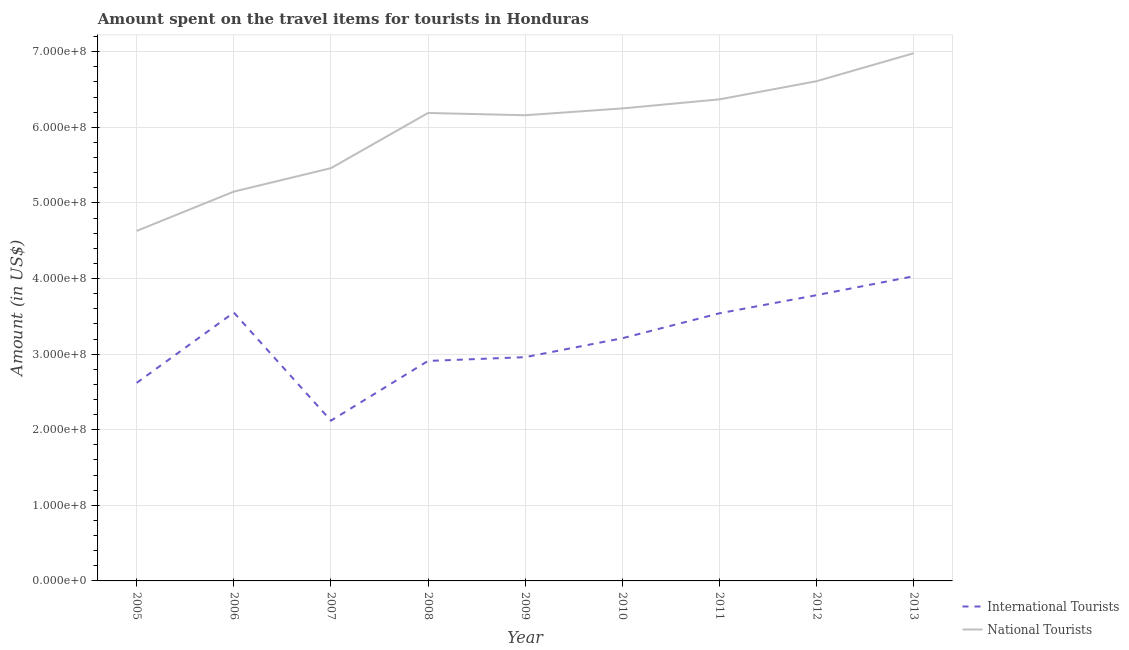Does the line corresponding to amount spent on travel items of national tourists intersect with the line corresponding to amount spent on travel items of international tourists?
Provide a succinct answer. No. What is the amount spent on travel items of international tourists in 2007?
Keep it short and to the point. 2.12e+08. Across all years, what is the maximum amount spent on travel items of international tourists?
Offer a terse response. 4.03e+08. Across all years, what is the minimum amount spent on travel items of national tourists?
Give a very brief answer. 4.63e+08. In which year was the amount spent on travel items of international tourists maximum?
Give a very brief answer. 2013. In which year was the amount spent on travel items of international tourists minimum?
Your answer should be very brief. 2007. What is the total amount spent on travel items of national tourists in the graph?
Provide a short and direct response. 5.38e+09. What is the difference between the amount spent on travel items of national tourists in 2005 and that in 2009?
Give a very brief answer. -1.53e+08. What is the difference between the amount spent on travel items of international tourists in 2013 and the amount spent on travel items of national tourists in 2009?
Provide a succinct answer. -2.13e+08. What is the average amount spent on travel items of international tourists per year?
Offer a terse response. 3.19e+08. In the year 2010, what is the difference between the amount spent on travel items of national tourists and amount spent on travel items of international tourists?
Your answer should be compact. 3.04e+08. In how many years, is the amount spent on travel items of national tourists greater than 560000000 US$?
Provide a succinct answer. 6. What is the ratio of the amount spent on travel items of international tourists in 2007 to that in 2009?
Your answer should be very brief. 0.72. What is the difference between the highest and the second highest amount spent on travel items of national tourists?
Provide a short and direct response. 3.70e+07. What is the difference between the highest and the lowest amount spent on travel items of international tourists?
Provide a succinct answer. 1.91e+08. In how many years, is the amount spent on travel items of international tourists greater than the average amount spent on travel items of international tourists taken over all years?
Offer a terse response. 5. Is the amount spent on travel items of national tourists strictly greater than the amount spent on travel items of international tourists over the years?
Give a very brief answer. Yes. Is the amount spent on travel items of international tourists strictly less than the amount spent on travel items of national tourists over the years?
Give a very brief answer. Yes. What is the difference between two consecutive major ticks on the Y-axis?
Your answer should be very brief. 1.00e+08. Does the graph contain any zero values?
Provide a short and direct response. No. Does the graph contain grids?
Keep it short and to the point. Yes. Where does the legend appear in the graph?
Ensure brevity in your answer.  Bottom right. What is the title of the graph?
Ensure brevity in your answer.  Amount spent on the travel items for tourists in Honduras. Does "Primary school" appear as one of the legend labels in the graph?
Provide a short and direct response. No. What is the label or title of the X-axis?
Provide a short and direct response. Year. What is the label or title of the Y-axis?
Make the answer very short. Amount (in US$). What is the Amount (in US$) of International Tourists in 2005?
Provide a succinct answer. 2.62e+08. What is the Amount (in US$) of National Tourists in 2005?
Provide a short and direct response. 4.63e+08. What is the Amount (in US$) of International Tourists in 2006?
Offer a very short reply. 3.55e+08. What is the Amount (in US$) in National Tourists in 2006?
Offer a terse response. 5.15e+08. What is the Amount (in US$) in International Tourists in 2007?
Make the answer very short. 2.12e+08. What is the Amount (in US$) in National Tourists in 2007?
Provide a short and direct response. 5.46e+08. What is the Amount (in US$) in International Tourists in 2008?
Keep it short and to the point. 2.91e+08. What is the Amount (in US$) of National Tourists in 2008?
Provide a succinct answer. 6.19e+08. What is the Amount (in US$) in International Tourists in 2009?
Provide a short and direct response. 2.96e+08. What is the Amount (in US$) in National Tourists in 2009?
Offer a terse response. 6.16e+08. What is the Amount (in US$) in International Tourists in 2010?
Provide a succinct answer. 3.21e+08. What is the Amount (in US$) of National Tourists in 2010?
Offer a terse response. 6.25e+08. What is the Amount (in US$) in International Tourists in 2011?
Offer a terse response. 3.54e+08. What is the Amount (in US$) of National Tourists in 2011?
Your response must be concise. 6.37e+08. What is the Amount (in US$) in International Tourists in 2012?
Provide a short and direct response. 3.78e+08. What is the Amount (in US$) in National Tourists in 2012?
Give a very brief answer. 6.61e+08. What is the Amount (in US$) in International Tourists in 2013?
Ensure brevity in your answer.  4.03e+08. What is the Amount (in US$) of National Tourists in 2013?
Give a very brief answer. 6.98e+08. Across all years, what is the maximum Amount (in US$) in International Tourists?
Give a very brief answer. 4.03e+08. Across all years, what is the maximum Amount (in US$) in National Tourists?
Keep it short and to the point. 6.98e+08. Across all years, what is the minimum Amount (in US$) of International Tourists?
Provide a succinct answer. 2.12e+08. Across all years, what is the minimum Amount (in US$) of National Tourists?
Give a very brief answer. 4.63e+08. What is the total Amount (in US$) in International Tourists in the graph?
Your response must be concise. 2.87e+09. What is the total Amount (in US$) of National Tourists in the graph?
Your answer should be very brief. 5.38e+09. What is the difference between the Amount (in US$) in International Tourists in 2005 and that in 2006?
Make the answer very short. -9.30e+07. What is the difference between the Amount (in US$) in National Tourists in 2005 and that in 2006?
Offer a very short reply. -5.20e+07. What is the difference between the Amount (in US$) of National Tourists in 2005 and that in 2007?
Keep it short and to the point. -8.30e+07. What is the difference between the Amount (in US$) in International Tourists in 2005 and that in 2008?
Your answer should be compact. -2.90e+07. What is the difference between the Amount (in US$) of National Tourists in 2005 and that in 2008?
Your answer should be very brief. -1.56e+08. What is the difference between the Amount (in US$) of International Tourists in 2005 and that in 2009?
Keep it short and to the point. -3.40e+07. What is the difference between the Amount (in US$) of National Tourists in 2005 and that in 2009?
Your answer should be compact. -1.53e+08. What is the difference between the Amount (in US$) in International Tourists in 2005 and that in 2010?
Your answer should be very brief. -5.90e+07. What is the difference between the Amount (in US$) of National Tourists in 2005 and that in 2010?
Your answer should be very brief. -1.62e+08. What is the difference between the Amount (in US$) of International Tourists in 2005 and that in 2011?
Make the answer very short. -9.20e+07. What is the difference between the Amount (in US$) of National Tourists in 2005 and that in 2011?
Ensure brevity in your answer.  -1.74e+08. What is the difference between the Amount (in US$) in International Tourists in 2005 and that in 2012?
Ensure brevity in your answer.  -1.16e+08. What is the difference between the Amount (in US$) of National Tourists in 2005 and that in 2012?
Provide a short and direct response. -1.98e+08. What is the difference between the Amount (in US$) in International Tourists in 2005 and that in 2013?
Provide a succinct answer. -1.41e+08. What is the difference between the Amount (in US$) in National Tourists in 2005 and that in 2013?
Provide a short and direct response. -2.35e+08. What is the difference between the Amount (in US$) in International Tourists in 2006 and that in 2007?
Give a very brief answer. 1.43e+08. What is the difference between the Amount (in US$) in National Tourists in 2006 and that in 2007?
Offer a very short reply. -3.10e+07. What is the difference between the Amount (in US$) of International Tourists in 2006 and that in 2008?
Offer a terse response. 6.40e+07. What is the difference between the Amount (in US$) in National Tourists in 2006 and that in 2008?
Offer a terse response. -1.04e+08. What is the difference between the Amount (in US$) of International Tourists in 2006 and that in 2009?
Make the answer very short. 5.90e+07. What is the difference between the Amount (in US$) of National Tourists in 2006 and that in 2009?
Keep it short and to the point. -1.01e+08. What is the difference between the Amount (in US$) in International Tourists in 2006 and that in 2010?
Ensure brevity in your answer.  3.40e+07. What is the difference between the Amount (in US$) of National Tourists in 2006 and that in 2010?
Provide a succinct answer. -1.10e+08. What is the difference between the Amount (in US$) in National Tourists in 2006 and that in 2011?
Your response must be concise. -1.22e+08. What is the difference between the Amount (in US$) of International Tourists in 2006 and that in 2012?
Give a very brief answer. -2.30e+07. What is the difference between the Amount (in US$) of National Tourists in 2006 and that in 2012?
Offer a very short reply. -1.46e+08. What is the difference between the Amount (in US$) in International Tourists in 2006 and that in 2013?
Ensure brevity in your answer.  -4.80e+07. What is the difference between the Amount (in US$) in National Tourists in 2006 and that in 2013?
Your response must be concise. -1.83e+08. What is the difference between the Amount (in US$) in International Tourists in 2007 and that in 2008?
Offer a terse response. -7.90e+07. What is the difference between the Amount (in US$) in National Tourists in 2007 and that in 2008?
Offer a very short reply. -7.30e+07. What is the difference between the Amount (in US$) in International Tourists in 2007 and that in 2009?
Offer a very short reply. -8.40e+07. What is the difference between the Amount (in US$) of National Tourists in 2007 and that in 2009?
Your response must be concise. -7.00e+07. What is the difference between the Amount (in US$) of International Tourists in 2007 and that in 2010?
Keep it short and to the point. -1.09e+08. What is the difference between the Amount (in US$) of National Tourists in 2007 and that in 2010?
Provide a succinct answer. -7.90e+07. What is the difference between the Amount (in US$) of International Tourists in 2007 and that in 2011?
Your answer should be very brief. -1.42e+08. What is the difference between the Amount (in US$) in National Tourists in 2007 and that in 2011?
Offer a terse response. -9.10e+07. What is the difference between the Amount (in US$) of International Tourists in 2007 and that in 2012?
Offer a very short reply. -1.66e+08. What is the difference between the Amount (in US$) of National Tourists in 2007 and that in 2012?
Provide a short and direct response. -1.15e+08. What is the difference between the Amount (in US$) of International Tourists in 2007 and that in 2013?
Offer a very short reply. -1.91e+08. What is the difference between the Amount (in US$) in National Tourists in 2007 and that in 2013?
Provide a succinct answer. -1.52e+08. What is the difference between the Amount (in US$) in International Tourists in 2008 and that in 2009?
Provide a short and direct response. -5.00e+06. What is the difference between the Amount (in US$) of National Tourists in 2008 and that in 2009?
Give a very brief answer. 3.00e+06. What is the difference between the Amount (in US$) in International Tourists in 2008 and that in 2010?
Your response must be concise. -3.00e+07. What is the difference between the Amount (in US$) of National Tourists in 2008 and that in 2010?
Ensure brevity in your answer.  -6.00e+06. What is the difference between the Amount (in US$) of International Tourists in 2008 and that in 2011?
Your answer should be compact. -6.30e+07. What is the difference between the Amount (in US$) in National Tourists in 2008 and that in 2011?
Provide a succinct answer. -1.80e+07. What is the difference between the Amount (in US$) in International Tourists in 2008 and that in 2012?
Offer a terse response. -8.70e+07. What is the difference between the Amount (in US$) in National Tourists in 2008 and that in 2012?
Provide a short and direct response. -4.20e+07. What is the difference between the Amount (in US$) in International Tourists in 2008 and that in 2013?
Offer a very short reply. -1.12e+08. What is the difference between the Amount (in US$) in National Tourists in 2008 and that in 2013?
Your answer should be very brief. -7.90e+07. What is the difference between the Amount (in US$) of International Tourists in 2009 and that in 2010?
Offer a very short reply. -2.50e+07. What is the difference between the Amount (in US$) of National Tourists in 2009 and that in 2010?
Provide a short and direct response. -9.00e+06. What is the difference between the Amount (in US$) in International Tourists in 2009 and that in 2011?
Make the answer very short. -5.80e+07. What is the difference between the Amount (in US$) in National Tourists in 2009 and that in 2011?
Offer a very short reply. -2.10e+07. What is the difference between the Amount (in US$) of International Tourists in 2009 and that in 2012?
Keep it short and to the point. -8.20e+07. What is the difference between the Amount (in US$) in National Tourists in 2009 and that in 2012?
Your answer should be compact. -4.50e+07. What is the difference between the Amount (in US$) of International Tourists in 2009 and that in 2013?
Your answer should be very brief. -1.07e+08. What is the difference between the Amount (in US$) of National Tourists in 2009 and that in 2013?
Give a very brief answer. -8.20e+07. What is the difference between the Amount (in US$) of International Tourists in 2010 and that in 2011?
Ensure brevity in your answer.  -3.30e+07. What is the difference between the Amount (in US$) in National Tourists in 2010 and that in 2011?
Provide a short and direct response. -1.20e+07. What is the difference between the Amount (in US$) in International Tourists in 2010 and that in 2012?
Make the answer very short. -5.70e+07. What is the difference between the Amount (in US$) in National Tourists in 2010 and that in 2012?
Provide a short and direct response. -3.60e+07. What is the difference between the Amount (in US$) of International Tourists in 2010 and that in 2013?
Offer a terse response. -8.20e+07. What is the difference between the Amount (in US$) of National Tourists in 2010 and that in 2013?
Provide a succinct answer. -7.30e+07. What is the difference between the Amount (in US$) in International Tourists in 2011 and that in 2012?
Ensure brevity in your answer.  -2.40e+07. What is the difference between the Amount (in US$) of National Tourists in 2011 and that in 2012?
Keep it short and to the point. -2.40e+07. What is the difference between the Amount (in US$) in International Tourists in 2011 and that in 2013?
Your response must be concise. -4.90e+07. What is the difference between the Amount (in US$) in National Tourists in 2011 and that in 2013?
Make the answer very short. -6.10e+07. What is the difference between the Amount (in US$) of International Tourists in 2012 and that in 2013?
Provide a short and direct response. -2.50e+07. What is the difference between the Amount (in US$) of National Tourists in 2012 and that in 2013?
Ensure brevity in your answer.  -3.70e+07. What is the difference between the Amount (in US$) in International Tourists in 2005 and the Amount (in US$) in National Tourists in 2006?
Offer a very short reply. -2.53e+08. What is the difference between the Amount (in US$) of International Tourists in 2005 and the Amount (in US$) of National Tourists in 2007?
Your answer should be very brief. -2.84e+08. What is the difference between the Amount (in US$) of International Tourists in 2005 and the Amount (in US$) of National Tourists in 2008?
Provide a short and direct response. -3.57e+08. What is the difference between the Amount (in US$) in International Tourists in 2005 and the Amount (in US$) in National Tourists in 2009?
Keep it short and to the point. -3.54e+08. What is the difference between the Amount (in US$) of International Tourists in 2005 and the Amount (in US$) of National Tourists in 2010?
Make the answer very short. -3.63e+08. What is the difference between the Amount (in US$) of International Tourists in 2005 and the Amount (in US$) of National Tourists in 2011?
Your response must be concise. -3.75e+08. What is the difference between the Amount (in US$) in International Tourists in 2005 and the Amount (in US$) in National Tourists in 2012?
Make the answer very short. -3.99e+08. What is the difference between the Amount (in US$) in International Tourists in 2005 and the Amount (in US$) in National Tourists in 2013?
Provide a short and direct response. -4.36e+08. What is the difference between the Amount (in US$) of International Tourists in 2006 and the Amount (in US$) of National Tourists in 2007?
Offer a terse response. -1.91e+08. What is the difference between the Amount (in US$) of International Tourists in 2006 and the Amount (in US$) of National Tourists in 2008?
Offer a terse response. -2.64e+08. What is the difference between the Amount (in US$) in International Tourists in 2006 and the Amount (in US$) in National Tourists in 2009?
Keep it short and to the point. -2.61e+08. What is the difference between the Amount (in US$) in International Tourists in 2006 and the Amount (in US$) in National Tourists in 2010?
Provide a succinct answer. -2.70e+08. What is the difference between the Amount (in US$) of International Tourists in 2006 and the Amount (in US$) of National Tourists in 2011?
Give a very brief answer. -2.82e+08. What is the difference between the Amount (in US$) in International Tourists in 2006 and the Amount (in US$) in National Tourists in 2012?
Keep it short and to the point. -3.06e+08. What is the difference between the Amount (in US$) in International Tourists in 2006 and the Amount (in US$) in National Tourists in 2013?
Provide a succinct answer. -3.43e+08. What is the difference between the Amount (in US$) in International Tourists in 2007 and the Amount (in US$) in National Tourists in 2008?
Give a very brief answer. -4.07e+08. What is the difference between the Amount (in US$) in International Tourists in 2007 and the Amount (in US$) in National Tourists in 2009?
Offer a very short reply. -4.04e+08. What is the difference between the Amount (in US$) of International Tourists in 2007 and the Amount (in US$) of National Tourists in 2010?
Offer a very short reply. -4.13e+08. What is the difference between the Amount (in US$) in International Tourists in 2007 and the Amount (in US$) in National Tourists in 2011?
Give a very brief answer. -4.25e+08. What is the difference between the Amount (in US$) of International Tourists in 2007 and the Amount (in US$) of National Tourists in 2012?
Ensure brevity in your answer.  -4.49e+08. What is the difference between the Amount (in US$) in International Tourists in 2007 and the Amount (in US$) in National Tourists in 2013?
Provide a succinct answer. -4.86e+08. What is the difference between the Amount (in US$) in International Tourists in 2008 and the Amount (in US$) in National Tourists in 2009?
Your answer should be very brief. -3.25e+08. What is the difference between the Amount (in US$) in International Tourists in 2008 and the Amount (in US$) in National Tourists in 2010?
Provide a succinct answer. -3.34e+08. What is the difference between the Amount (in US$) of International Tourists in 2008 and the Amount (in US$) of National Tourists in 2011?
Provide a short and direct response. -3.46e+08. What is the difference between the Amount (in US$) in International Tourists in 2008 and the Amount (in US$) in National Tourists in 2012?
Your answer should be compact. -3.70e+08. What is the difference between the Amount (in US$) of International Tourists in 2008 and the Amount (in US$) of National Tourists in 2013?
Give a very brief answer. -4.07e+08. What is the difference between the Amount (in US$) in International Tourists in 2009 and the Amount (in US$) in National Tourists in 2010?
Provide a short and direct response. -3.29e+08. What is the difference between the Amount (in US$) of International Tourists in 2009 and the Amount (in US$) of National Tourists in 2011?
Give a very brief answer. -3.41e+08. What is the difference between the Amount (in US$) in International Tourists in 2009 and the Amount (in US$) in National Tourists in 2012?
Offer a terse response. -3.65e+08. What is the difference between the Amount (in US$) in International Tourists in 2009 and the Amount (in US$) in National Tourists in 2013?
Your answer should be compact. -4.02e+08. What is the difference between the Amount (in US$) in International Tourists in 2010 and the Amount (in US$) in National Tourists in 2011?
Provide a succinct answer. -3.16e+08. What is the difference between the Amount (in US$) of International Tourists in 2010 and the Amount (in US$) of National Tourists in 2012?
Your response must be concise. -3.40e+08. What is the difference between the Amount (in US$) of International Tourists in 2010 and the Amount (in US$) of National Tourists in 2013?
Offer a very short reply. -3.77e+08. What is the difference between the Amount (in US$) of International Tourists in 2011 and the Amount (in US$) of National Tourists in 2012?
Your response must be concise. -3.07e+08. What is the difference between the Amount (in US$) in International Tourists in 2011 and the Amount (in US$) in National Tourists in 2013?
Your response must be concise. -3.44e+08. What is the difference between the Amount (in US$) of International Tourists in 2012 and the Amount (in US$) of National Tourists in 2013?
Your response must be concise. -3.20e+08. What is the average Amount (in US$) in International Tourists per year?
Your response must be concise. 3.19e+08. What is the average Amount (in US$) of National Tourists per year?
Provide a succinct answer. 5.98e+08. In the year 2005, what is the difference between the Amount (in US$) of International Tourists and Amount (in US$) of National Tourists?
Offer a very short reply. -2.01e+08. In the year 2006, what is the difference between the Amount (in US$) of International Tourists and Amount (in US$) of National Tourists?
Give a very brief answer. -1.60e+08. In the year 2007, what is the difference between the Amount (in US$) in International Tourists and Amount (in US$) in National Tourists?
Provide a short and direct response. -3.34e+08. In the year 2008, what is the difference between the Amount (in US$) in International Tourists and Amount (in US$) in National Tourists?
Provide a short and direct response. -3.28e+08. In the year 2009, what is the difference between the Amount (in US$) of International Tourists and Amount (in US$) of National Tourists?
Make the answer very short. -3.20e+08. In the year 2010, what is the difference between the Amount (in US$) of International Tourists and Amount (in US$) of National Tourists?
Ensure brevity in your answer.  -3.04e+08. In the year 2011, what is the difference between the Amount (in US$) of International Tourists and Amount (in US$) of National Tourists?
Your answer should be very brief. -2.83e+08. In the year 2012, what is the difference between the Amount (in US$) of International Tourists and Amount (in US$) of National Tourists?
Keep it short and to the point. -2.83e+08. In the year 2013, what is the difference between the Amount (in US$) in International Tourists and Amount (in US$) in National Tourists?
Ensure brevity in your answer.  -2.95e+08. What is the ratio of the Amount (in US$) of International Tourists in 2005 to that in 2006?
Offer a terse response. 0.74. What is the ratio of the Amount (in US$) of National Tourists in 2005 to that in 2006?
Keep it short and to the point. 0.9. What is the ratio of the Amount (in US$) of International Tourists in 2005 to that in 2007?
Ensure brevity in your answer.  1.24. What is the ratio of the Amount (in US$) of National Tourists in 2005 to that in 2007?
Offer a very short reply. 0.85. What is the ratio of the Amount (in US$) of International Tourists in 2005 to that in 2008?
Give a very brief answer. 0.9. What is the ratio of the Amount (in US$) of National Tourists in 2005 to that in 2008?
Provide a short and direct response. 0.75. What is the ratio of the Amount (in US$) of International Tourists in 2005 to that in 2009?
Offer a terse response. 0.89. What is the ratio of the Amount (in US$) of National Tourists in 2005 to that in 2009?
Provide a succinct answer. 0.75. What is the ratio of the Amount (in US$) of International Tourists in 2005 to that in 2010?
Ensure brevity in your answer.  0.82. What is the ratio of the Amount (in US$) in National Tourists in 2005 to that in 2010?
Provide a short and direct response. 0.74. What is the ratio of the Amount (in US$) in International Tourists in 2005 to that in 2011?
Provide a short and direct response. 0.74. What is the ratio of the Amount (in US$) in National Tourists in 2005 to that in 2011?
Your response must be concise. 0.73. What is the ratio of the Amount (in US$) of International Tourists in 2005 to that in 2012?
Provide a short and direct response. 0.69. What is the ratio of the Amount (in US$) of National Tourists in 2005 to that in 2012?
Keep it short and to the point. 0.7. What is the ratio of the Amount (in US$) in International Tourists in 2005 to that in 2013?
Keep it short and to the point. 0.65. What is the ratio of the Amount (in US$) of National Tourists in 2005 to that in 2013?
Ensure brevity in your answer.  0.66. What is the ratio of the Amount (in US$) of International Tourists in 2006 to that in 2007?
Your answer should be very brief. 1.67. What is the ratio of the Amount (in US$) in National Tourists in 2006 to that in 2007?
Offer a terse response. 0.94. What is the ratio of the Amount (in US$) in International Tourists in 2006 to that in 2008?
Offer a terse response. 1.22. What is the ratio of the Amount (in US$) of National Tourists in 2006 to that in 2008?
Make the answer very short. 0.83. What is the ratio of the Amount (in US$) of International Tourists in 2006 to that in 2009?
Offer a very short reply. 1.2. What is the ratio of the Amount (in US$) of National Tourists in 2006 to that in 2009?
Make the answer very short. 0.84. What is the ratio of the Amount (in US$) in International Tourists in 2006 to that in 2010?
Keep it short and to the point. 1.11. What is the ratio of the Amount (in US$) of National Tourists in 2006 to that in 2010?
Offer a very short reply. 0.82. What is the ratio of the Amount (in US$) in International Tourists in 2006 to that in 2011?
Keep it short and to the point. 1. What is the ratio of the Amount (in US$) of National Tourists in 2006 to that in 2011?
Keep it short and to the point. 0.81. What is the ratio of the Amount (in US$) in International Tourists in 2006 to that in 2012?
Offer a terse response. 0.94. What is the ratio of the Amount (in US$) of National Tourists in 2006 to that in 2012?
Your answer should be very brief. 0.78. What is the ratio of the Amount (in US$) of International Tourists in 2006 to that in 2013?
Give a very brief answer. 0.88. What is the ratio of the Amount (in US$) of National Tourists in 2006 to that in 2013?
Your response must be concise. 0.74. What is the ratio of the Amount (in US$) of International Tourists in 2007 to that in 2008?
Provide a short and direct response. 0.73. What is the ratio of the Amount (in US$) of National Tourists in 2007 to that in 2008?
Offer a very short reply. 0.88. What is the ratio of the Amount (in US$) of International Tourists in 2007 to that in 2009?
Your answer should be very brief. 0.72. What is the ratio of the Amount (in US$) in National Tourists in 2007 to that in 2009?
Your answer should be very brief. 0.89. What is the ratio of the Amount (in US$) of International Tourists in 2007 to that in 2010?
Make the answer very short. 0.66. What is the ratio of the Amount (in US$) in National Tourists in 2007 to that in 2010?
Offer a terse response. 0.87. What is the ratio of the Amount (in US$) in International Tourists in 2007 to that in 2011?
Provide a succinct answer. 0.6. What is the ratio of the Amount (in US$) in International Tourists in 2007 to that in 2012?
Your response must be concise. 0.56. What is the ratio of the Amount (in US$) of National Tourists in 2007 to that in 2012?
Ensure brevity in your answer.  0.83. What is the ratio of the Amount (in US$) of International Tourists in 2007 to that in 2013?
Offer a terse response. 0.53. What is the ratio of the Amount (in US$) of National Tourists in 2007 to that in 2013?
Offer a very short reply. 0.78. What is the ratio of the Amount (in US$) of International Tourists in 2008 to that in 2009?
Your answer should be very brief. 0.98. What is the ratio of the Amount (in US$) of National Tourists in 2008 to that in 2009?
Provide a short and direct response. 1. What is the ratio of the Amount (in US$) of International Tourists in 2008 to that in 2010?
Make the answer very short. 0.91. What is the ratio of the Amount (in US$) of National Tourists in 2008 to that in 2010?
Ensure brevity in your answer.  0.99. What is the ratio of the Amount (in US$) in International Tourists in 2008 to that in 2011?
Offer a terse response. 0.82. What is the ratio of the Amount (in US$) of National Tourists in 2008 to that in 2011?
Provide a succinct answer. 0.97. What is the ratio of the Amount (in US$) in International Tourists in 2008 to that in 2012?
Give a very brief answer. 0.77. What is the ratio of the Amount (in US$) in National Tourists in 2008 to that in 2012?
Give a very brief answer. 0.94. What is the ratio of the Amount (in US$) of International Tourists in 2008 to that in 2013?
Make the answer very short. 0.72. What is the ratio of the Amount (in US$) of National Tourists in 2008 to that in 2013?
Your answer should be compact. 0.89. What is the ratio of the Amount (in US$) in International Tourists in 2009 to that in 2010?
Your answer should be very brief. 0.92. What is the ratio of the Amount (in US$) in National Tourists in 2009 to that in 2010?
Make the answer very short. 0.99. What is the ratio of the Amount (in US$) of International Tourists in 2009 to that in 2011?
Provide a succinct answer. 0.84. What is the ratio of the Amount (in US$) of National Tourists in 2009 to that in 2011?
Keep it short and to the point. 0.97. What is the ratio of the Amount (in US$) of International Tourists in 2009 to that in 2012?
Offer a terse response. 0.78. What is the ratio of the Amount (in US$) of National Tourists in 2009 to that in 2012?
Your answer should be very brief. 0.93. What is the ratio of the Amount (in US$) of International Tourists in 2009 to that in 2013?
Offer a very short reply. 0.73. What is the ratio of the Amount (in US$) in National Tourists in 2009 to that in 2013?
Offer a very short reply. 0.88. What is the ratio of the Amount (in US$) in International Tourists in 2010 to that in 2011?
Offer a very short reply. 0.91. What is the ratio of the Amount (in US$) in National Tourists in 2010 to that in 2011?
Provide a short and direct response. 0.98. What is the ratio of the Amount (in US$) of International Tourists in 2010 to that in 2012?
Offer a terse response. 0.85. What is the ratio of the Amount (in US$) in National Tourists in 2010 to that in 2012?
Ensure brevity in your answer.  0.95. What is the ratio of the Amount (in US$) in International Tourists in 2010 to that in 2013?
Your answer should be very brief. 0.8. What is the ratio of the Amount (in US$) of National Tourists in 2010 to that in 2013?
Ensure brevity in your answer.  0.9. What is the ratio of the Amount (in US$) of International Tourists in 2011 to that in 2012?
Your answer should be very brief. 0.94. What is the ratio of the Amount (in US$) in National Tourists in 2011 to that in 2012?
Make the answer very short. 0.96. What is the ratio of the Amount (in US$) in International Tourists in 2011 to that in 2013?
Give a very brief answer. 0.88. What is the ratio of the Amount (in US$) in National Tourists in 2011 to that in 2013?
Provide a succinct answer. 0.91. What is the ratio of the Amount (in US$) of International Tourists in 2012 to that in 2013?
Offer a very short reply. 0.94. What is the ratio of the Amount (in US$) of National Tourists in 2012 to that in 2013?
Your response must be concise. 0.95. What is the difference between the highest and the second highest Amount (in US$) in International Tourists?
Ensure brevity in your answer.  2.50e+07. What is the difference between the highest and the second highest Amount (in US$) in National Tourists?
Your answer should be very brief. 3.70e+07. What is the difference between the highest and the lowest Amount (in US$) in International Tourists?
Give a very brief answer. 1.91e+08. What is the difference between the highest and the lowest Amount (in US$) of National Tourists?
Make the answer very short. 2.35e+08. 